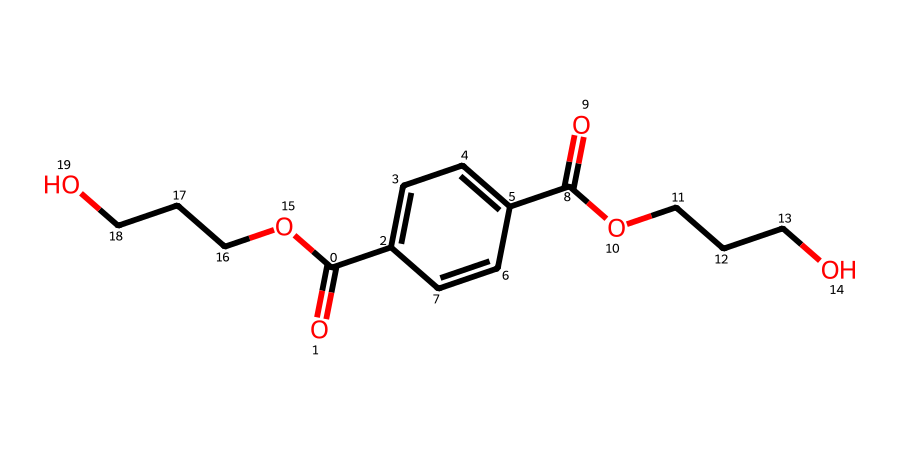What is the total number of carbon atoms in this structure? Counting the carbon atoms in the provided SMILES representation, we find that there are a total of 15 carbon atoms.
Answer: 15 What functional groups are present in this chemical? By analyzing the SMILES, we can identify carboxylic acid (–COOH) and ester (–O–C=O) functional groups. These are indicated by the corresponding structures present in the chemical.
Answer: carboxylic acid, ester How many oxygen atoms are in this molecule? In the SMILES representation, there are a total of 6 oxygen atoms counted from the various functional groups (2 from the carboxylic acid and 4 from the esters).
Answer: 6 Is this chemical biodegradable? Considering that this substance is derived from polyethylene terephthalate (PET), it is known to be less biodegradable than other organic materials, hence it is usually considered non-biodegradable under standard conditions.
Answer: no What type of plastic is this compound primarily used for? The structure's resemblance to polyethylene terephthalate suggests it is primarily used in the production of polyester products, particularly beverage bottles, thus making it a recycling target.
Answer: polyester 